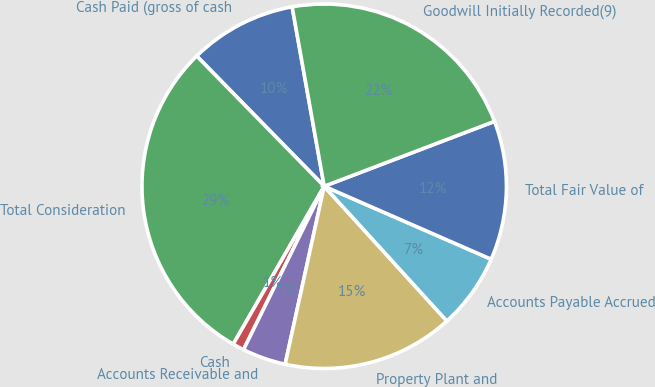<chart> <loc_0><loc_0><loc_500><loc_500><pie_chart><fcel>Cash Paid (gross of cash<fcel>Total Consideration<fcel>Cash<fcel>Accounts Receivable and<fcel>Property Plant and<fcel>Accounts Payable Accrued<fcel>Total Fair Value of<fcel>Goodwill Initially Recorded(9)<nl><fcel>9.52%<fcel>29.35%<fcel>1.02%<fcel>3.86%<fcel>15.19%<fcel>6.69%<fcel>12.35%<fcel>22.02%<nl></chart> 